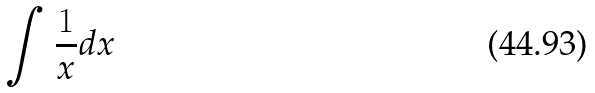<formula> <loc_0><loc_0><loc_500><loc_500>\int \frac { 1 } { x } d x</formula> 